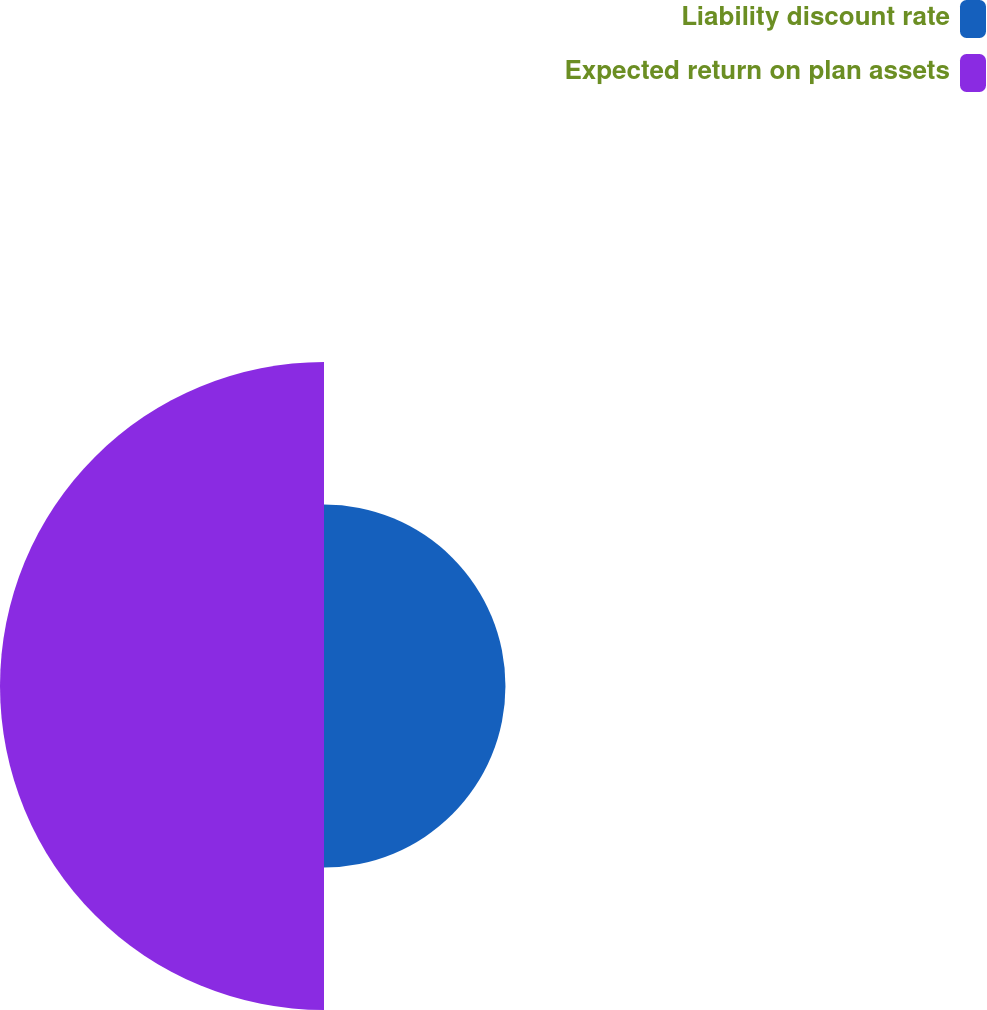<chart> <loc_0><loc_0><loc_500><loc_500><pie_chart><fcel>Liability discount rate<fcel>Expected return on plan assets<nl><fcel>35.9%<fcel>64.1%<nl></chart> 